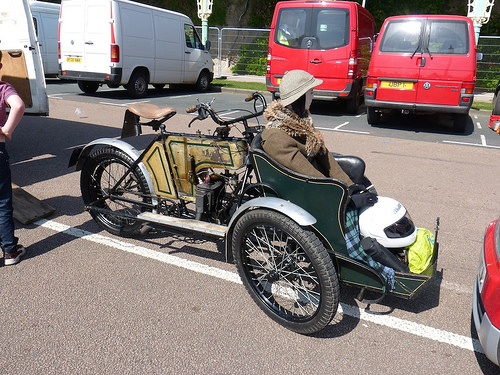<image>
Is there a helmet on the road? No. The helmet is not positioned on the road. They may be near each other, but the helmet is not supported by or resting on top of the road. 